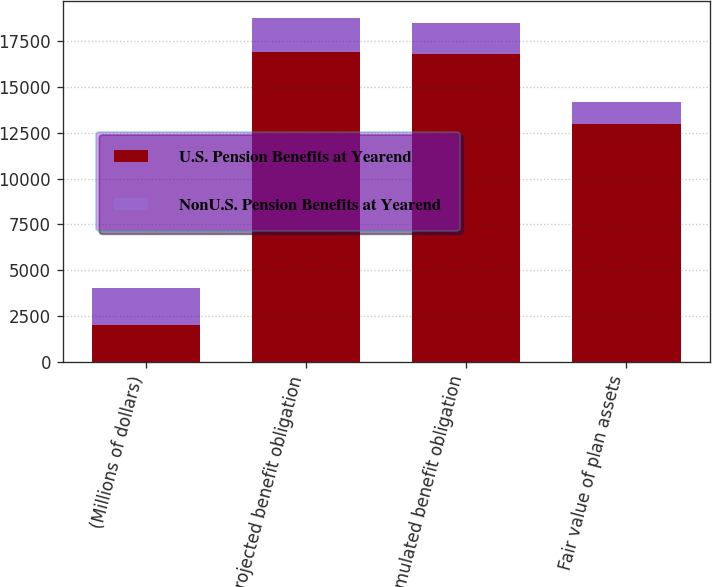Convert chart to OTSL. <chart><loc_0><loc_0><loc_500><loc_500><stacked_bar_chart><ecel><fcel>(Millions of dollars)<fcel>Projected benefit obligation<fcel>Accumulated benefit obligation<fcel>Fair value of plan assets<nl><fcel>U.S. Pension Benefits at Yearend<fcel>2017<fcel>16904<fcel>16761<fcel>12975<nl><fcel>NonU.S. Pension Benefits at Yearend<fcel>2017<fcel>1853<fcel>1708<fcel>1194<nl></chart> 